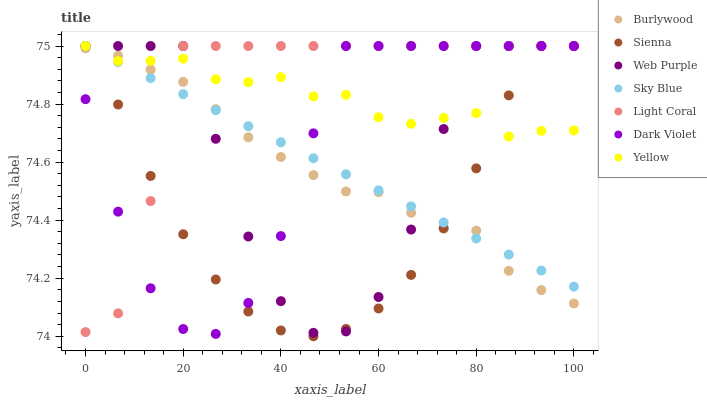Does Sienna have the minimum area under the curve?
Answer yes or no. Yes. Does Light Coral have the maximum area under the curve?
Answer yes or no. Yes. Does Burlywood have the minimum area under the curve?
Answer yes or no. No. Does Burlywood have the maximum area under the curve?
Answer yes or no. No. Is Sky Blue the smoothest?
Answer yes or no. Yes. Is Web Purple the roughest?
Answer yes or no. Yes. Is Burlywood the smoothest?
Answer yes or no. No. Is Burlywood the roughest?
Answer yes or no. No. Does Sienna have the lowest value?
Answer yes or no. Yes. Does Burlywood have the lowest value?
Answer yes or no. No. Does Sky Blue have the highest value?
Answer yes or no. Yes. Does Burlywood have the highest value?
Answer yes or no. No. Does Burlywood intersect Yellow?
Answer yes or no. Yes. Is Burlywood less than Yellow?
Answer yes or no. No. Is Burlywood greater than Yellow?
Answer yes or no. No. 